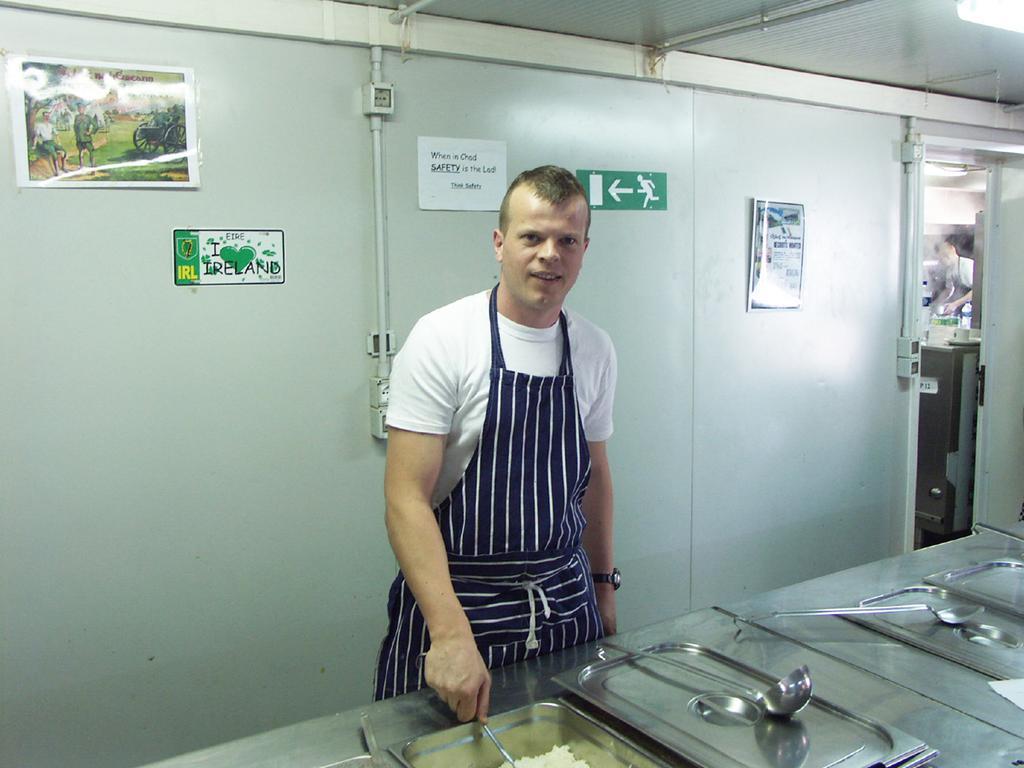Can you describe this image briefly? In this image a person wearing a apron is standing behind the table having few vessels and spoons on it. Behind him there are few posts attached to the wall. Beside there is a door from which a person and table having a cup on it are visible. In vessel there is some food. Person is holding the spoon in his hand. Right top there is a light attached to the roof. 